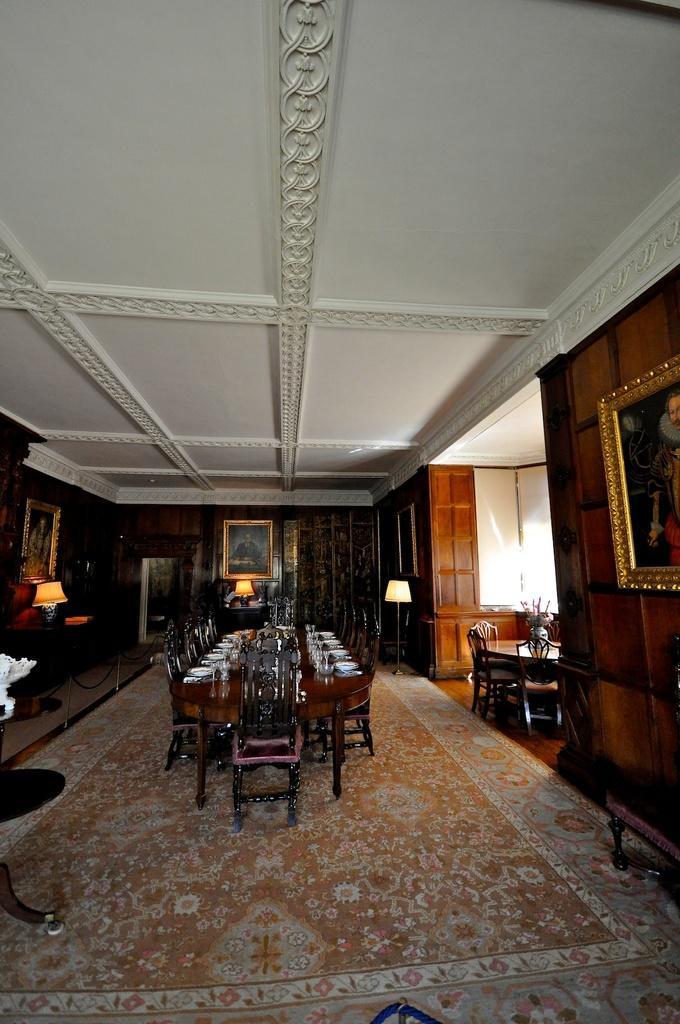Describe this image in one or two sentences. In this image there are tables, chairs, flower vases,plates, glasses, carpet, lamps, frames attached to the wall, and some objects on the table. 